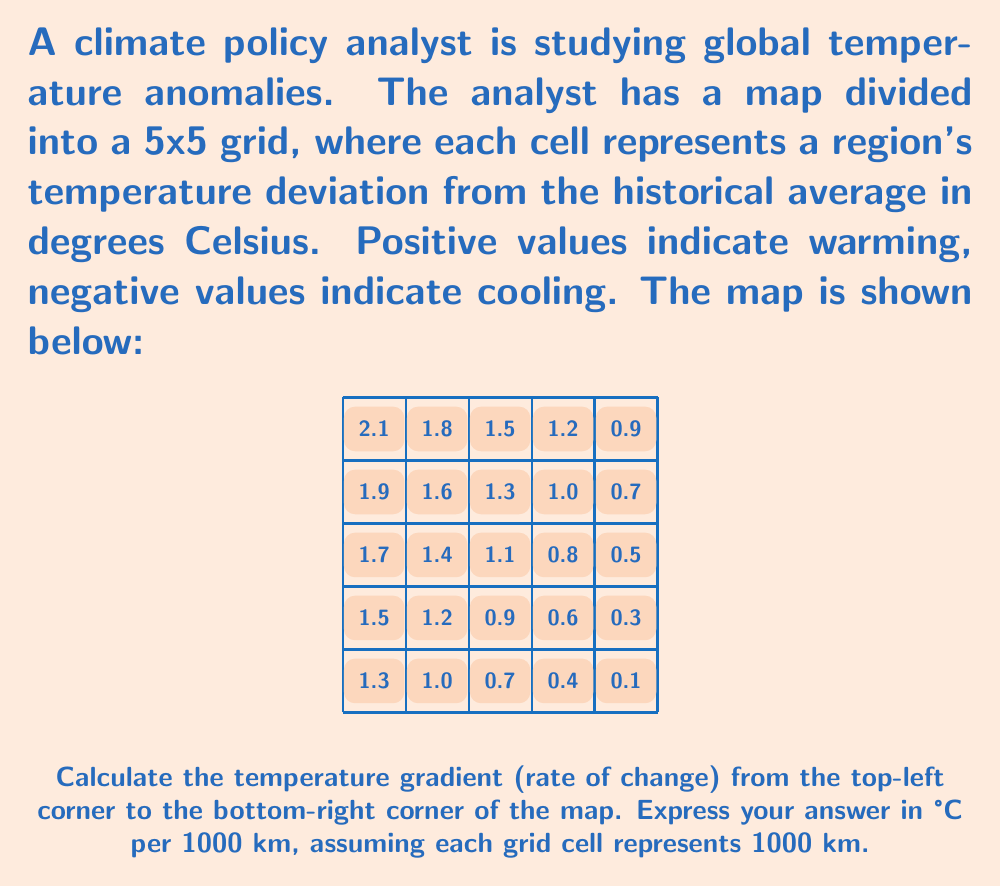Could you help me with this problem? To calculate the temperature gradient, we need to:

1. Find the temperature difference between the top-left and bottom-right corners:
   Top-left temperature: $2.1°C$
   Bottom-right temperature: $0.1°C$
   Temperature difference: $2.1°C - 0.1°C = 2.0°C$

2. Determine the distance between these points:
   The map is a 5x5 grid, so the diagonal distance is $\sqrt{5^2 + 5^2} = \sqrt{50} \approx 7.07$ grid cells.
   
   If each cell represents 1000 km, the total distance is:
   $7.07 \times 1000 \text{ km} = 7070 \text{ km}$

3. Calculate the gradient:
   Gradient = Temperature change / Distance
   $$ \text{Gradient} = \frac{2.0°C}{7070 \text{ km}} \approx 0.000283 °C/\text{km} $$

4. Convert to °C per 1000 km:
   $$ 0.000283 °C/\text{km} \times 1000 = 0.283 °C/1000\text{ km} $$

Therefore, the temperature gradient from the top-left to the bottom-right corner is approximately $0.283°C$ per 1000 km.
Answer: $0.283°C/1000\text{ km}$ 